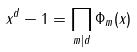<formula> <loc_0><loc_0><loc_500><loc_500>x ^ { d } - 1 = \prod _ { m | d } \Phi _ { m } ( x )</formula> 